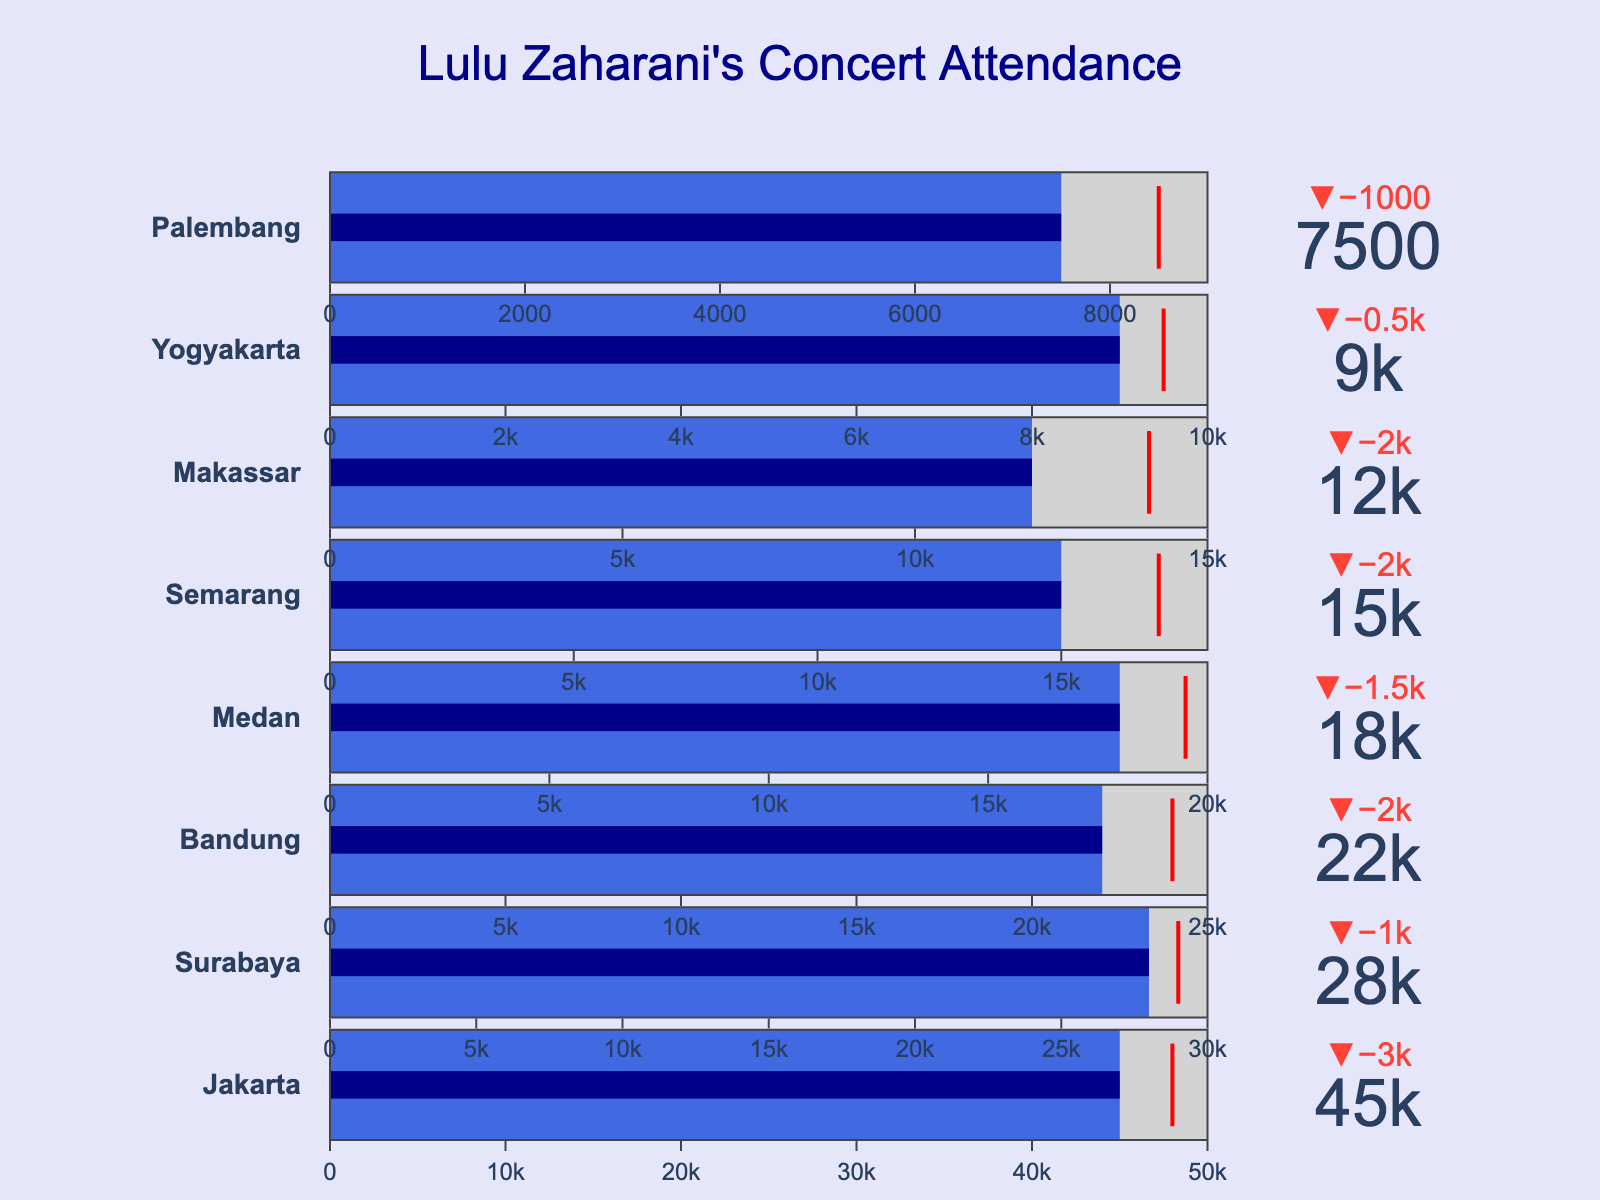What's the title of the figure? The title of the figure is usually displayed prominently at the top and it's meant to summarize what the figure is about. In this case, it reads "Lulu Zaharani's Concert Attendance".
Answer: Lulu Zaharani's Concert Attendance How many cities are shown in the figure? To find the number of cities, count the individual bullet charts or city names listed. The cities in the dataset are Jakarta, Surabaya, Bandung, Medan, Semarang, Makassar, Yogyakarta, Palembang, which total to 8.
Answer: 8 What city had the highest attendance at Lulu Zaharani's concerts? To determine this, compare the 'Attendance' values of each city. According to the data, Jakarta has the highest attendance of 45,000.
Answer: Jakarta Which city had an attendance closest to its target? This requires finding the city where the 'Attendance' value is closest to the 'Target' value. Bandung has an attendance of 22,000 and a target of 24,000, making the difference 2,000, which is less than in any other city.
Answer: Bandung What is the attendance difference between Jakarta and Surabaya? Subtract Surabaya’s attendance from Jakarta’s attendance: 45,000 (Jakarta) - 28,000 (Surabaya) = 17,000.
Answer: 17,000 Which city fell short of its capacity by the largest amount? Calculate the shortfall for each city by subtracting the 'Attendance' from the 'Capacity'. Jakarta: 50,000 - 45,000 = 5,000; Surabaya: 30,000 - 28,000 = 2,000; Bandung: 25,000 - 22,000 = 3,000; Medan: 20,000 - 18,000 = 2,000; Semarang: 18,000 - 15,000 = 3,000; Makassar: 15,000 - 12,000 = 3,000; Yogyakarta: 10,000 - 9,000 = 1,000; Palembang: 9,000 - 7,500 = 1,500. Jakarta has the largest shortfall of 5,000.
Answer: Jakarta Did any city exceed its target attendance? Look at the 'Attendance' values compared to the 'Target' values. No cities exceeded their target, as all Attendance values are less than or equal to their Targets.
Answer: No What's the range of attendance values across all cities? Identify the smallest and largest attendance figures and calculate the range. The smallest attendance is 7,500 (Palembang) and the largest is 45,000 (Jakarta). Therefore, the range is 45,000 - 7,500 = 37,500.
Answer: 37,500 Which cities had attendances greater than 15,000 but less than 25,000? Identify cities with attendance figures within the specified range: Bandung (22,000), Medan (18,000), and Semarang (15,000) fit this criteria.
Answer: Bandung, Medan, Semarang 